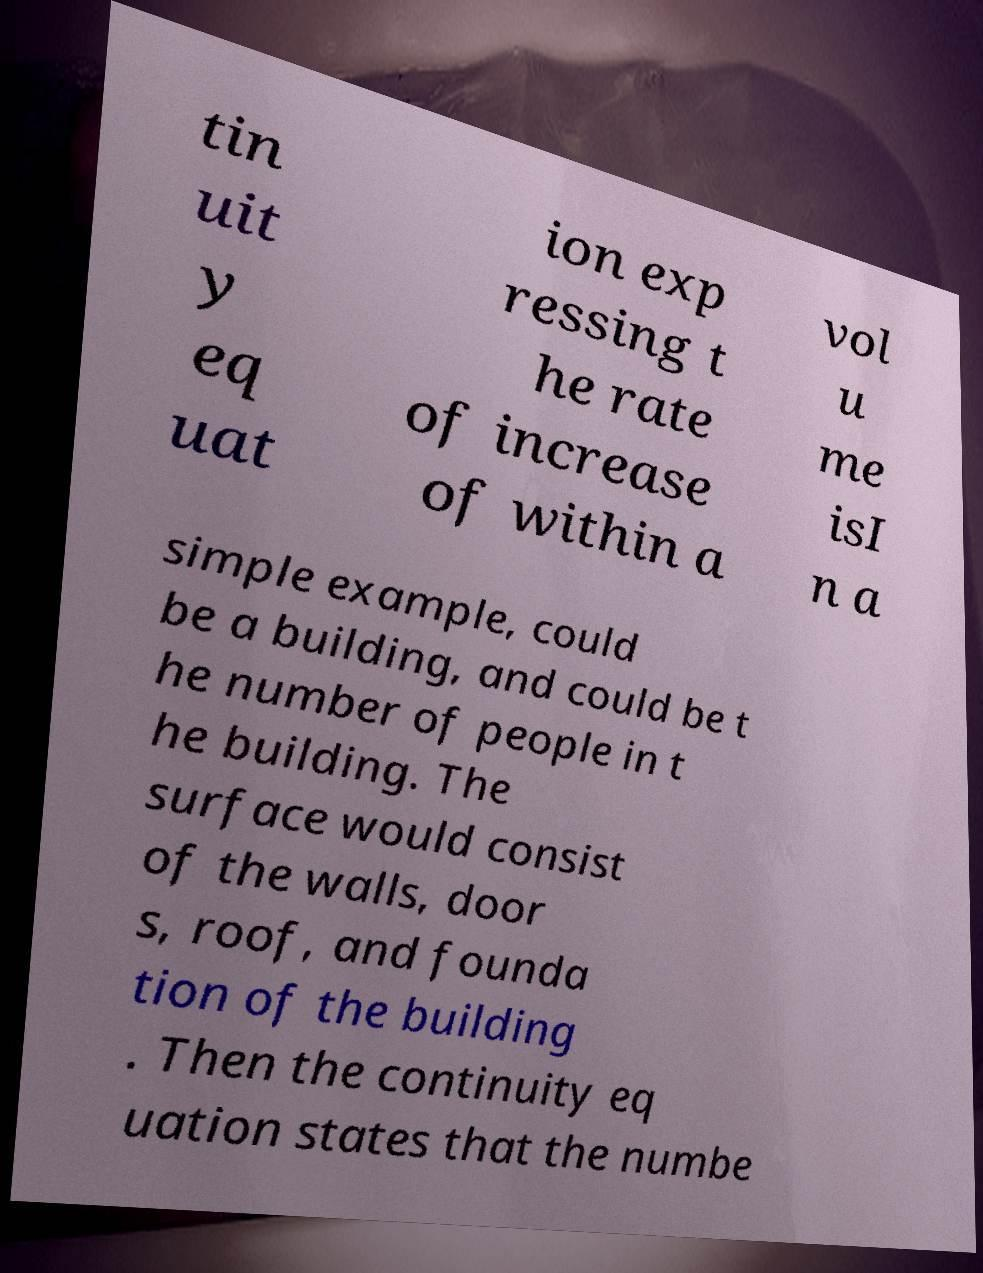Could you assist in decoding the text presented in this image and type it out clearly? tin uit y eq uat ion exp ressing t he rate of increase of within a vol u me isI n a simple example, could be a building, and could be t he number of people in t he building. The surface would consist of the walls, door s, roof, and founda tion of the building . Then the continuity eq uation states that the numbe 